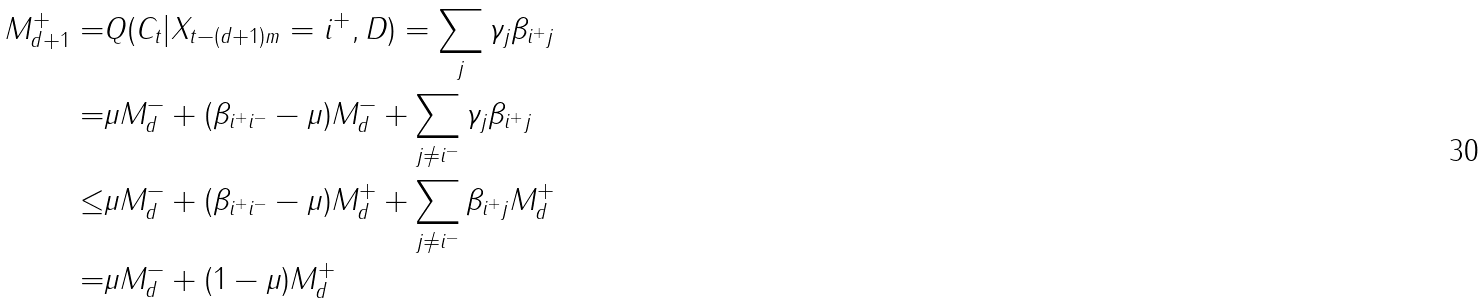<formula> <loc_0><loc_0><loc_500><loc_500>M _ { d + 1 } ^ { + } = & Q ( C _ { t } | X _ { t - ( d + 1 ) m } = i ^ { + } , D ) = \sum _ { j } \gamma _ { j } \beta _ { i ^ { + } j } \\ = & \mu M _ { d } ^ { - } + ( \beta _ { i ^ { + } i ^ { - } } - \mu ) M _ { d } ^ { - } + \sum _ { j \neq i ^ { - } } \gamma _ { j } \beta _ { i ^ { + } j } \\ \leq & \mu M _ { d } ^ { - } + ( \beta _ { i ^ { + } i ^ { - } } - \mu ) M _ { d } ^ { + } + \sum _ { j \neq i ^ { - } } \beta _ { i ^ { + } j } M _ { d } ^ { + } \\ = & \mu M _ { d } ^ { - } + ( 1 - \mu ) M _ { d } ^ { + }</formula> 